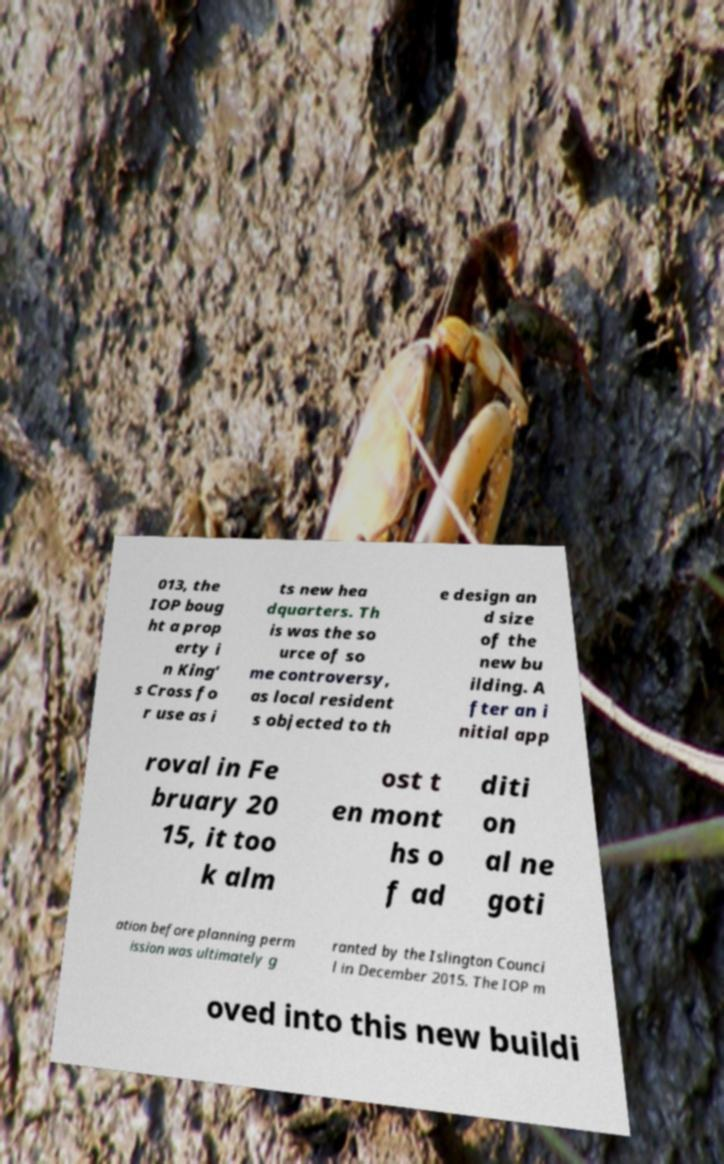Could you assist in decoding the text presented in this image and type it out clearly? 013, the IOP boug ht a prop erty i n King’ s Cross fo r use as i ts new hea dquarters. Th is was the so urce of so me controversy, as local resident s objected to th e design an d size of the new bu ilding. A fter an i nitial app roval in Fe bruary 20 15, it too k alm ost t en mont hs o f ad diti on al ne goti ation before planning perm ission was ultimately g ranted by the Islington Counci l in December 2015. The IOP m oved into this new buildi 